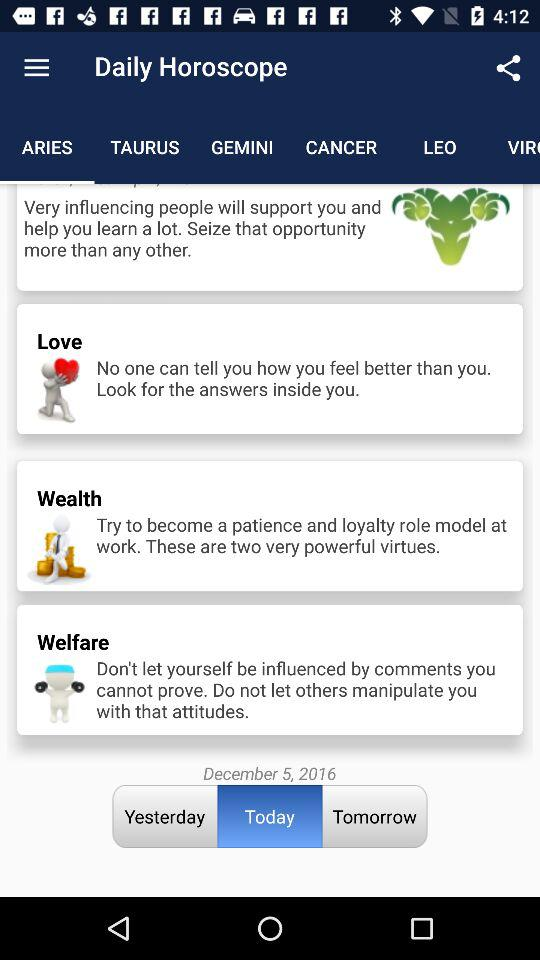Which category of daily horoscope am I in? You are in the "ARIES" category. 